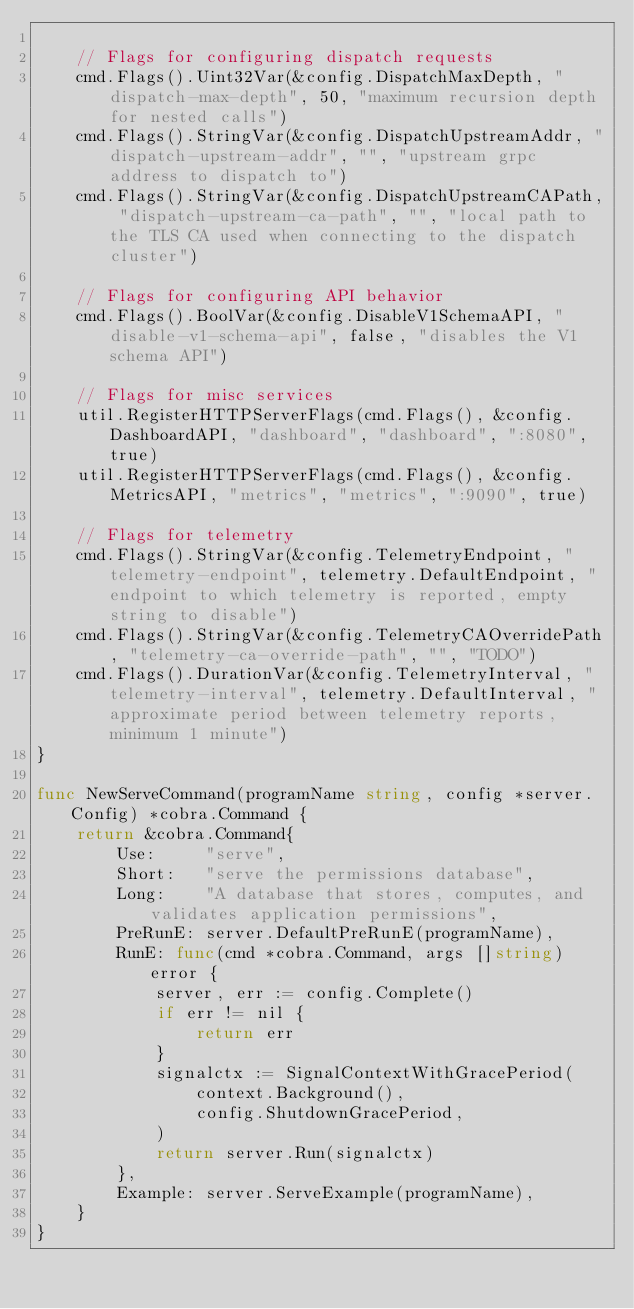Convert code to text. <code><loc_0><loc_0><loc_500><loc_500><_Go_>
	// Flags for configuring dispatch requests
	cmd.Flags().Uint32Var(&config.DispatchMaxDepth, "dispatch-max-depth", 50, "maximum recursion depth for nested calls")
	cmd.Flags().StringVar(&config.DispatchUpstreamAddr, "dispatch-upstream-addr", "", "upstream grpc address to dispatch to")
	cmd.Flags().StringVar(&config.DispatchUpstreamCAPath, "dispatch-upstream-ca-path", "", "local path to the TLS CA used when connecting to the dispatch cluster")

	// Flags for configuring API behavior
	cmd.Flags().BoolVar(&config.DisableV1SchemaAPI, "disable-v1-schema-api", false, "disables the V1 schema API")

	// Flags for misc services
	util.RegisterHTTPServerFlags(cmd.Flags(), &config.DashboardAPI, "dashboard", "dashboard", ":8080", true)
	util.RegisterHTTPServerFlags(cmd.Flags(), &config.MetricsAPI, "metrics", "metrics", ":9090", true)

	// Flags for telemetry
	cmd.Flags().StringVar(&config.TelemetryEndpoint, "telemetry-endpoint", telemetry.DefaultEndpoint, "endpoint to which telemetry is reported, empty string to disable")
	cmd.Flags().StringVar(&config.TelemetryCAOverridePath, "telemetry-ca-override-path", "", "TODO")
	cmd.Flags().DurationVar(&config.TelemetryInterval, "telemetry-interval", telemetry.DefaultInterval, "approximate period between telemetry reports, minimum 1 minute")
}

func NewServeCommand(programName string, config *server.Config) *cobra.Command {
	return &cobra.Command{
		Use:     "serve",
		Short:   "serve the permissions database",
		Long:    "A database that stores, computes, and validates application permissions",
		PreRunE: server.DefaultPreRunE(programName),
		RunE: func(cmd *cobra.Command, args []string) error {
			server, err := config.Complete()
			if err != nil {
				return err
			}
			signalctx := SignalContextWithGracePeriod(
				context.Background(),
				config.ShutdownGracePeriod,
			)
			return server.Run(signalctx)
		},
		Example: server.ServeExample(programName),
	}
}
</code> 